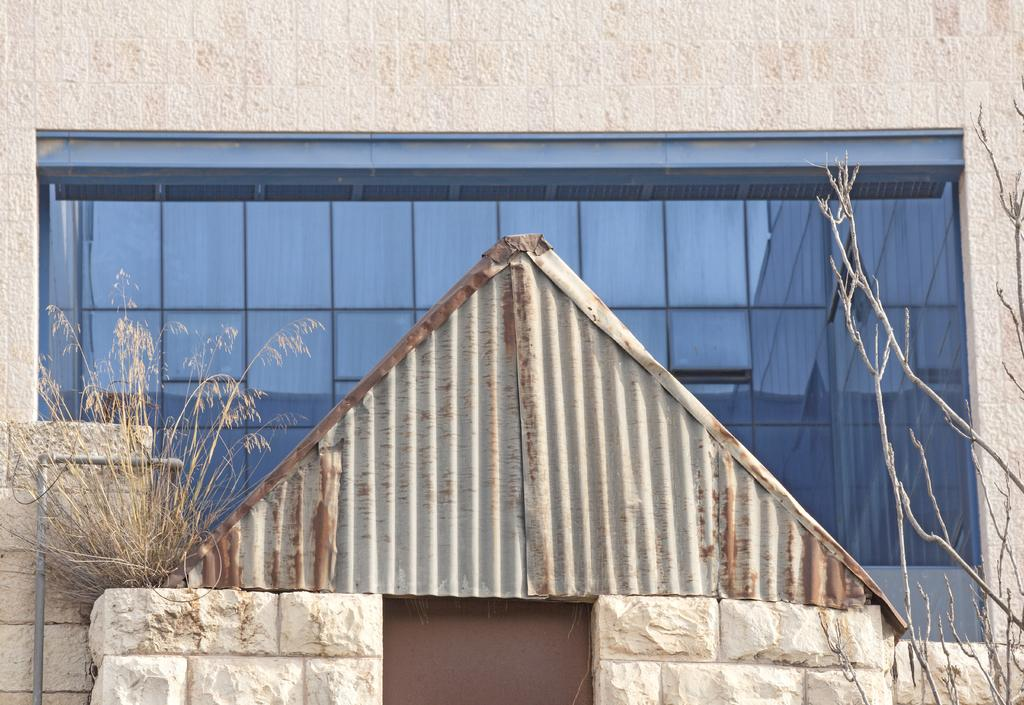What type of structure is visible in the image? There is a building in the image. What material is present in the image? Glass is present in the image. What type of vegetation can be seen in the image? There are plants and a tree in the image. What architectural feature is visible in the image? There is a door in the image. What type of construction material is visible in the image? Metal rods are visible in the image. What time of day is suggested by the image? The image was likely taken during the day. What type of apparatus is being used to prepare breakfast in the image? There is no apparatus or breakfast present in the image. What advice might the grandmother give to the person in the image? There is no person or grandmother present in the image. 